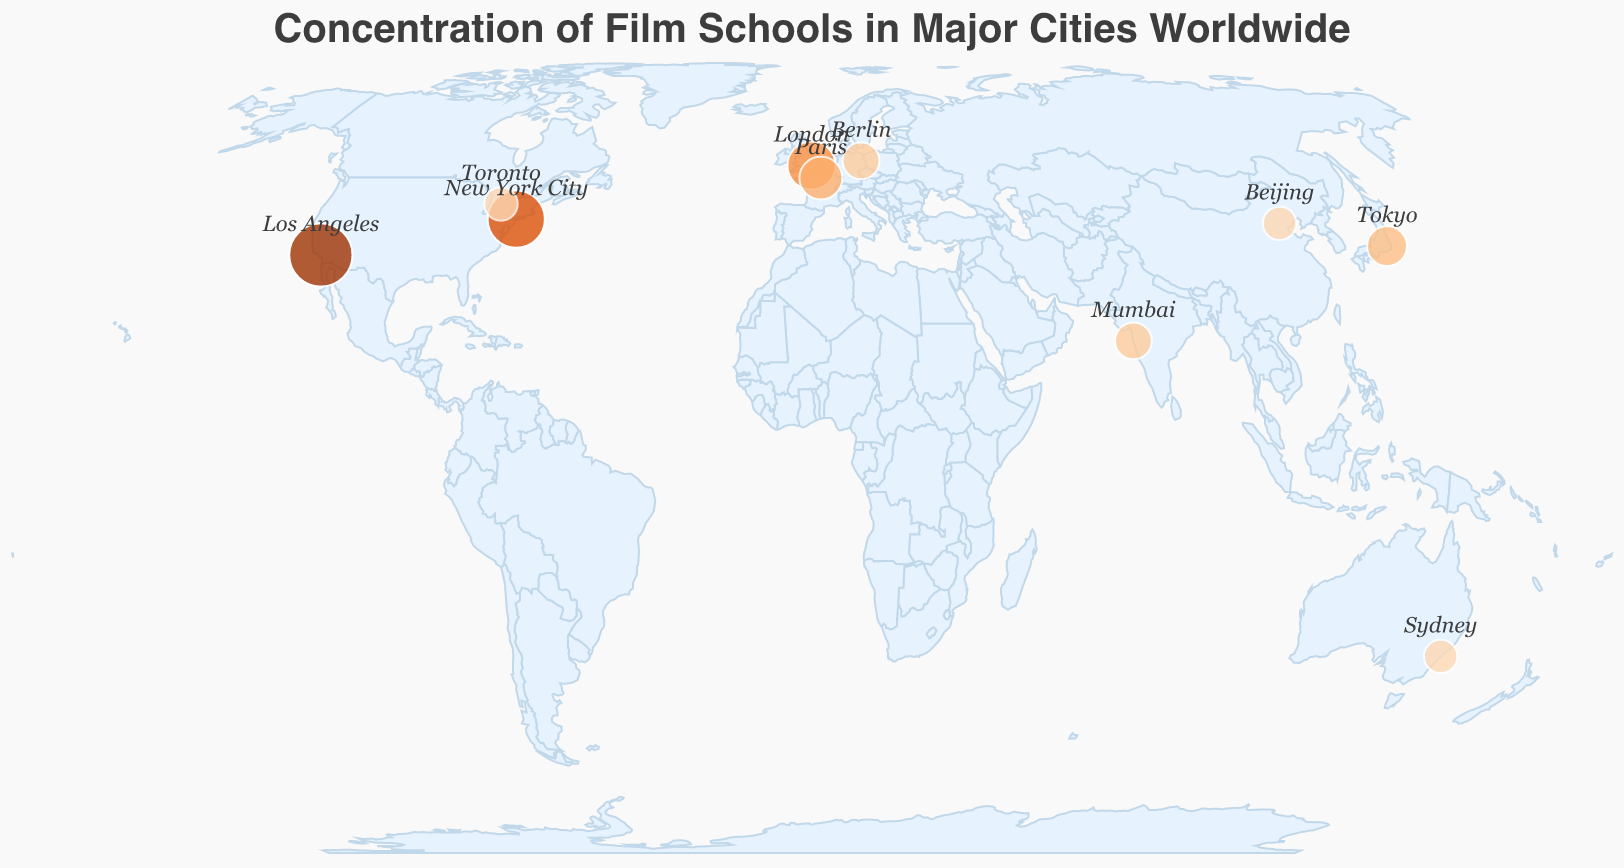What's the city with the highest number of film schools? The circle with the largest size and darkest color represents the city with the highest concentration of film schools, which is labeled "Los Angeles".
Answer: Los Angeles Which cities have the same number of film schools? From the circles' sizes and their associated text, the cities of Toronto, Sydney, and Beijing all have 3 film schools each.
Answer: Toronto, Sydney, and Beijing Which city in Europe has the least concentration of film schools? Among the European cities represented, Berlin has 4 film schools and London has 8, and Berlin is the city with the least concentration.
Answer: Berlin What notable program is associated with Mumbai? Hovering over or checking the tooltip information for Mumbai shows that the notable program is the "Film and Television Institute of India".
Answer: Film and Television Institute of India How many film schools are there collectively in the USA? Adding up the number of film schools in Los Angeles (15) and New York City (12) gives a total of 27 film schools in the USA.
Answer: 27 Which city is located at a latitude of 51.5074 and offers a notable program called the National Film and Television School? Checking the latitude and the notable program mentioned in the figure, London matches these criteria.
Answer: London Which city has a higher number of film schools, Berlin or Tokyo? Comparing the film schools count between Berlin (4) and Tokyo (5) shows that Tokyo has more film schools.
Answer: Tokyo What is the common visual characteristic used to represent the number of film schools in the cities on the map? The circles' sizes vary to represent the number of film schools; larger circles indicate more film schools.
Answer: Circle size How many notable programs are listed in Asian cities, and what are they? The notable programs in Asian cities are in Tokyo ("Tokyo University of the Arts"), Mumbai ("Film and Television Institute of India"), and Beijing ("Beijing Film Academy"), totaling three programs.
Answer: 3 programs: Tokyo University of the Arts, Film and Television Institute of India, Beijing Film Academy Which city pairs have a difference of more than 10 film schools between them? By comparing the film schools count, the pairs Los Angeles (15) vs. all *other cities except New York (12)* have more than 10 film schools difference.
Answer: Los Angeles and *other cities* (except New York City) 